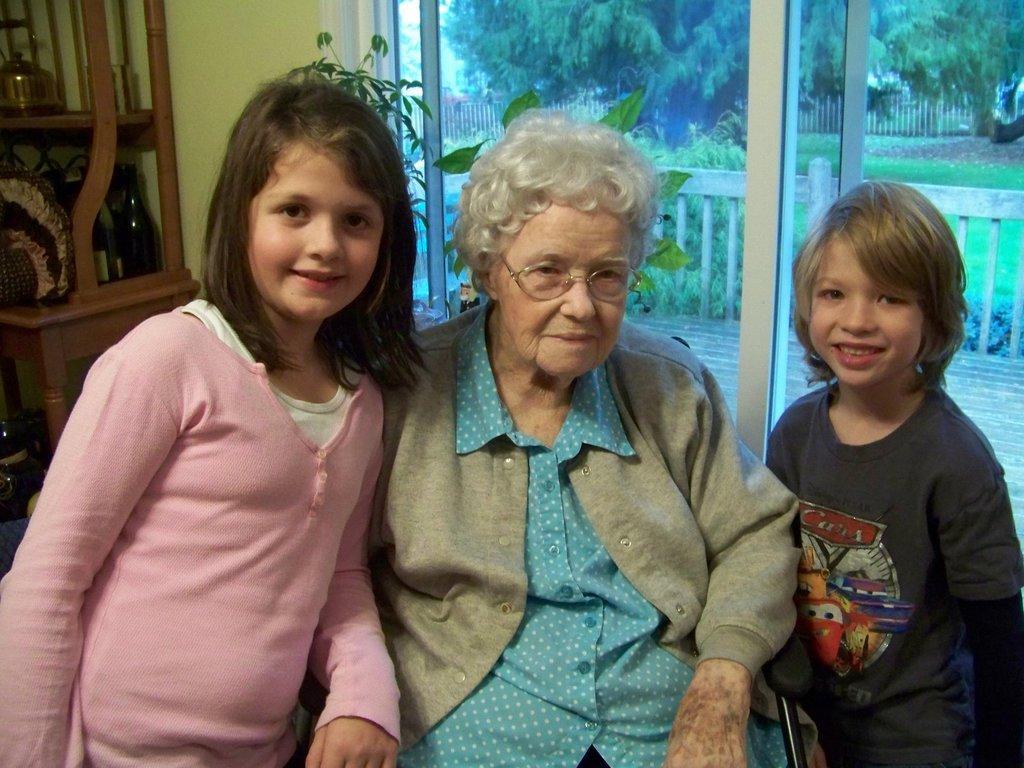Please provide a concise description of this image. In this image we can see a woman, a boy and a girl. The woman is wearing a blue color shirt, grey sweater and glasses. The girl is wearing a pink color top and the boy is wearing a T-shirt. In the background of the image, we can see glass door. Behind the door, there are trees, fencing, plants and grassy land. On the left side of the image, we can see bottles and things on a wooden shelf. 